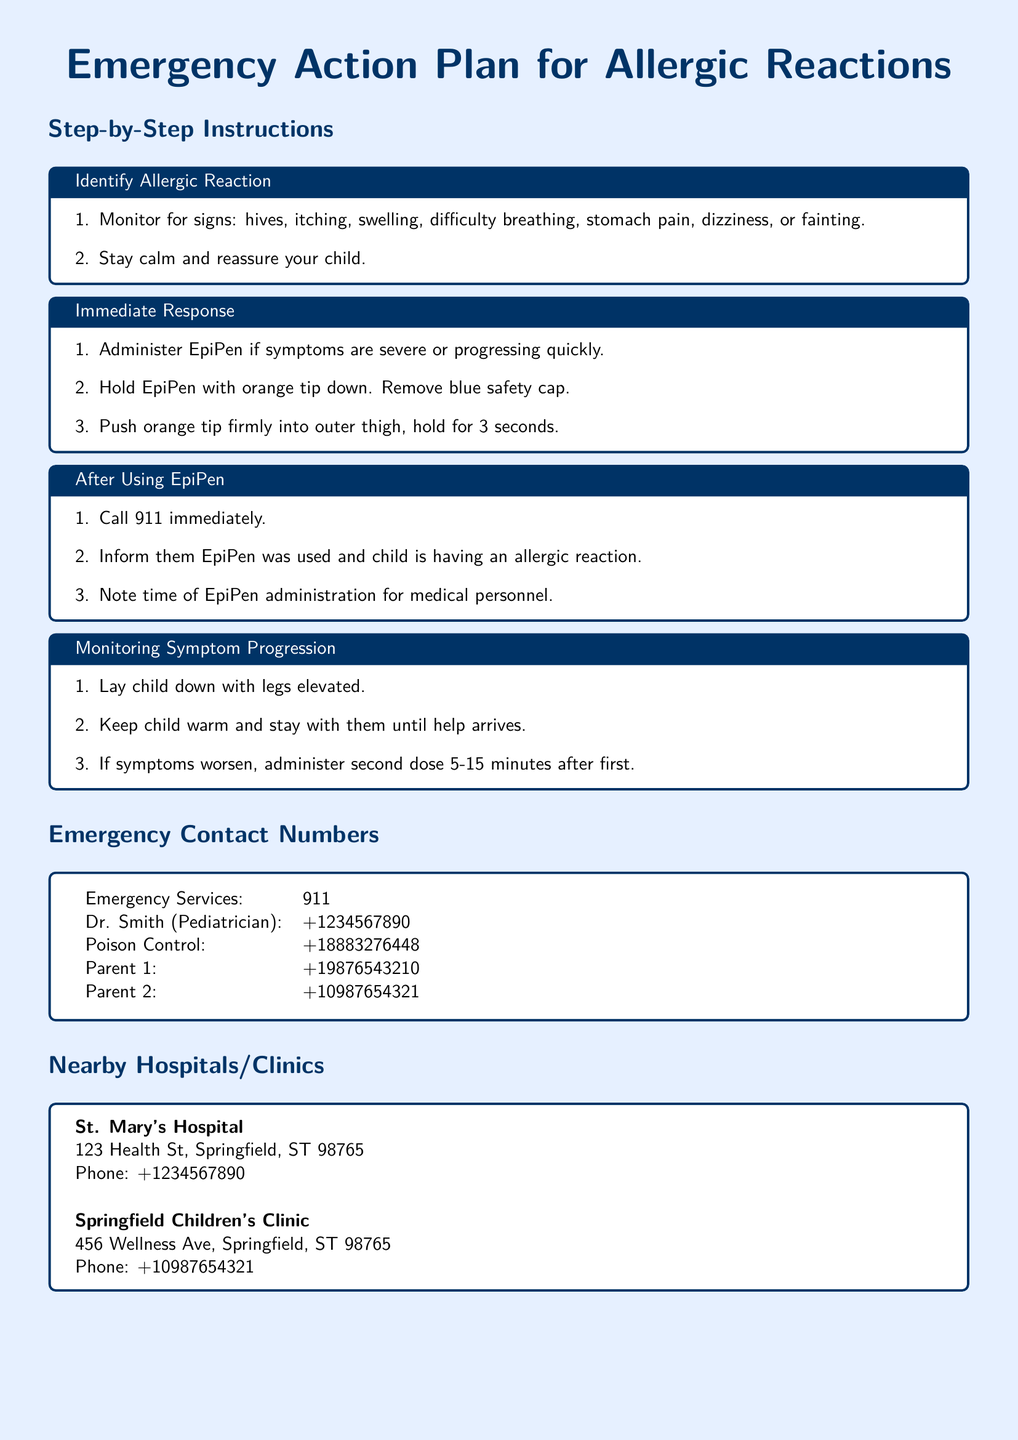What is the emergency services number? The emergency services number is listed in the Emergency Contact Numbers section of the document.
Answer: 911 What should you monitor for signs of an allergic reaction? This information is provided in the Identify Allergic Reaction section, indicating specific symptoms to watch for.
Answer: hives, itching, swelling, difficulty breathing, stomach pain, dizziness, fainting What should be done immediately after using the EpiPen? The Immediate Response section outlines steps to take immediately after administering the EpiPen.
Answer: Call 911 immediately How long should the EpiPen be held in place? The instructions for using the EpiPen specify how long it should be administered.
Answer: 3 seconds What is the address of St. Mary's Hospital? The document contains specific information about nearby hospitals and clinics, including their addresses.
Answer: 123 Health St, Springfield, ST 98765 How long after the first dose can a second dose of EpiPen be administered? The Monitoring Symptom Progression section mentions a time frame for administering a second dose.
Answer: 5-15 minutes Who is the pediatrician listed in the document? The Emergency Contact Numbers section includes specific details, like names and contact information for medical professionals.
Answer: Dr. Smith What should be done if symptoms worsen after using the EpiPen? The document provides guidance on actions to take if symptoms do not improve after the EpiPen is used.
Answer: administer second dose 